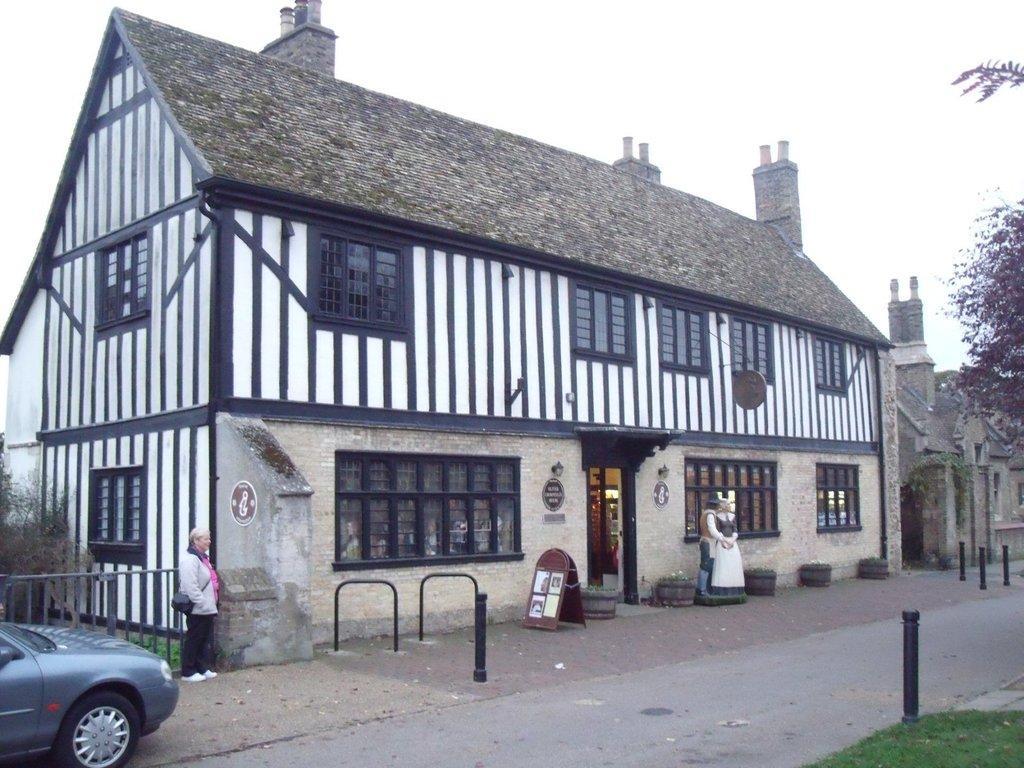How would you summarize this image in a sentence or two? In this image there is the sky, there are buildings, there is a building truncated towards the right of the image, there are windows, there are objects on the building, there are objects on the ground, there is a board, there are papers on the board, there is a person standing and wearing a bag, there is a fencing truncated towards the left of the image, there is a tree truncated towards the left of the image, there is a car truncated towards the left of the image, there is the road, there is a tree truncated towards the right of the image, there is grass truncated towards the right of the image, there is a statue of a person. 